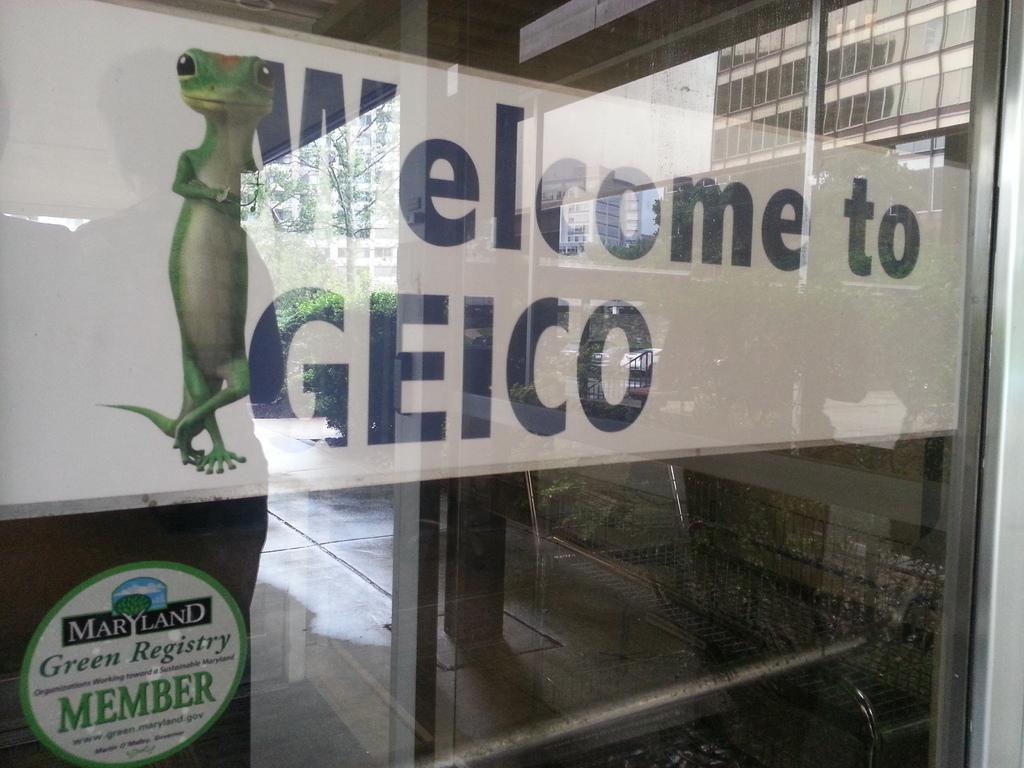Could you give a brief overview of what you see in this image? In this image we can see a glass door with text and image and through the glass we can see few trees and buildings. 